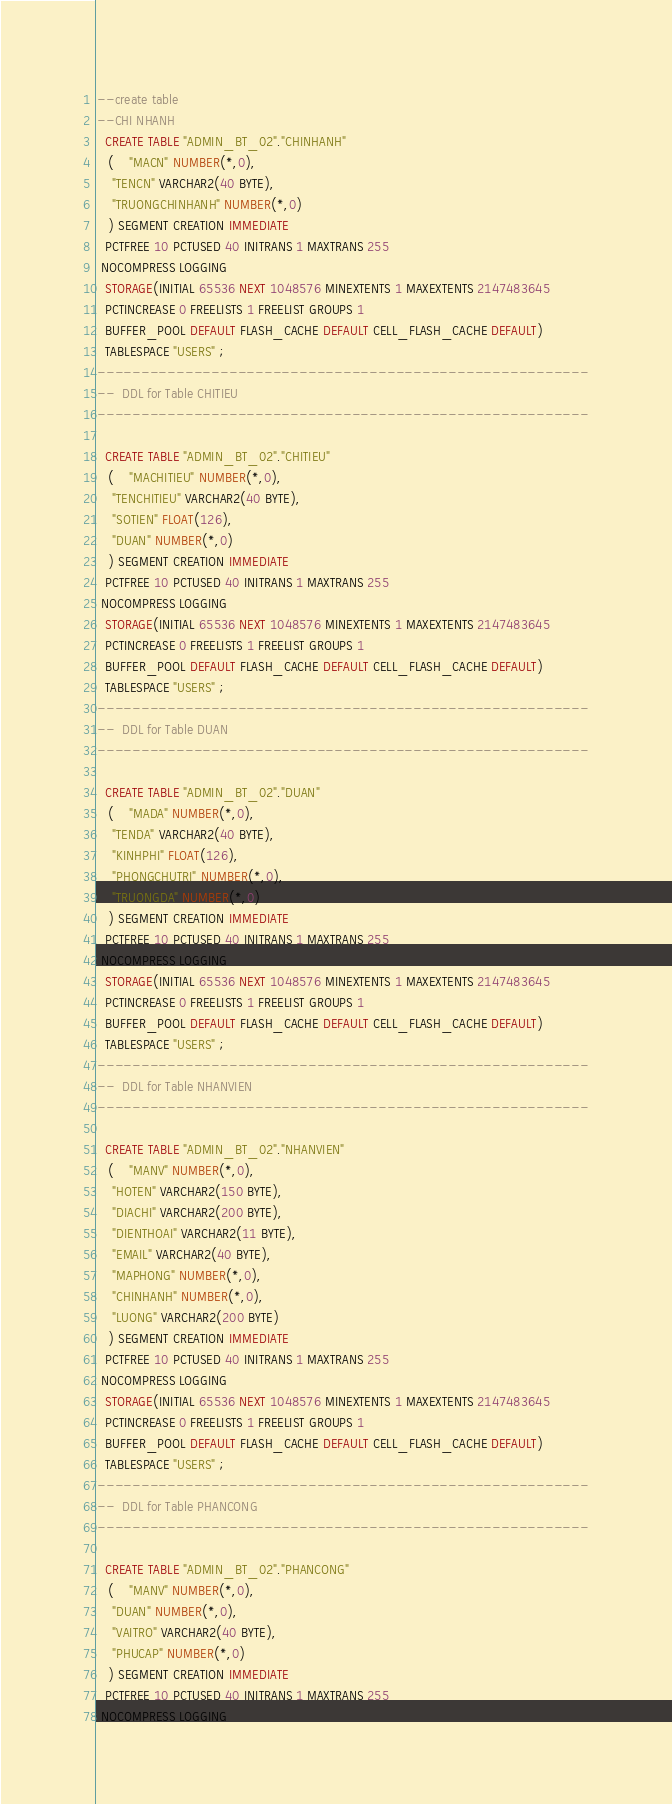<code> <loc_0><loc_0><loc_500><loc_500><_SQL_>--create table
--CHI NHANH
  CREATE TABLE "ADMIN_BT_02"."CHINHANH" 
   (	"MACN" NUMBER(*,0), 
	"TENCN" VARCHAR2(40 BYTE), 
	"TRUONGCHINHANH" NUMBER(*,0)
   ) SEGMENT CREATION IMMEDIATE 
  PCTFREE 10 PCTUSED 40 INITRANS 1 MAXTRANS 255 
 NOCOMPRESS LOGGING
  STORAGE(INITIAL 65536 NEXT 1048576 MINEXTENTS 1 MAXEXTENTS 2147483645
  PCTINCREASE 0 FREELISTS 1 FREELIST GROUPS 1
  BUFFER_POOL DEFAULT FLASH_CACHE DEFAULT CELL_FLASH_CACHE DEFAULT)
  TABLESPACE "USERS" ;
--------------------------------------------------------
--  DDL for Table CHITIEU
--------------------------------------------------------

  CREATE TABLE "ADMIN_BT_02"."CHITIEU" 
   (	"MACHITIEU" NUMBER(*,0), 
	"TENCHITIEU" VARCHAR2(40 BYTE), 
	"SOTIEN" FLOAT(126), 
	"DUAN" NUMBER(*,0)
   ) SEGMENT CREATION IMMEDIATE 
  PCTFREE 10 PCTUSED 40 INITRANS 1 MAXTRANS 255 
 NOCOMPRESS LOGGING
  STORAGE(INITIAL 65536 NEXT 1048576 MINEXTENTS 1 MAXEXTENTS 2147483645
  PCTINCREASE 0 FREELISTS 1 FREELIST GROUPS 1
  BUFFER_POOL DEFAULT FLASH_CACHE DEFAULT CELL_FLASH_CACHE DEFAULT)
  TABLESPACE "USERS" ;
--------------------------------------------------------
--  DDL for Table DUAN
--------------------------------------------------------

  CREATE TABLE "ADMIN_BT_02"."DUAN" 
   (	"MADA" NUMBER(*,0), 
	"TENDA" VARCHAR2(40 BYTE), 
	"KINHPHI" FLOAT(126), 
	"PHONGCHUTRI" NUMBER(*,0), 
	"TRUONGDA" NUMBER(*,0)
   ) SEGMENT CREATION IMMEDIATE 
  PCTFREE 10 PCTUSED 40 INITRANS 1 MAXTRANS 255 
 NOCOMPRESS LOGGING
  STORAGE(INITIAL 65536 NEXT 1048576 MINEXTENTS 1 MAXEXTENTS 2147483645
  PCTINCREASE 0 FREELISTS 1 FREELIST GROUPS 1
  BUFFER_POOL DEFAULT FLASH_CACHE DEFAULT CELL_FLASH_CACHE DEFAULT)
  TABLESPACE "USERS" ;
--------------------------------------------------------
--  DDL for Table NHANVIEN
--------------------------------------------------------

  CREATE TABLE "ADMIN_BT_02"."NHANVIEN" 
   (	"MANV" NUMBER(*,0), 
	"HOTEN" VARCHAR2(150 BYTE), 
	"DIACHI" VARCHAR2(200 BYTE), 
	"DIENTHOAI" VARCHAR2(11 BYTE), 
	"EMAIL" VARCHAR2(40 BYTE), 
	"MAPHONG" NUMBER(*,0), 
	"CHINHANH" NUMBER(*,0), 
	"LUONG" VARCHAR2(200 BYTE)
   ) SEGMENT CREATION IMMEDIATE 
  PCTFREE 10 PCTUSED 40 INITRANS 1 MAXTRANS 255 
 NOCOMPRESS LOGGING
  STORAGE(INITIAL 65536 NEXT 1048576 MINEXTENTS 1 MAXEXTENTS 2147483645
  PCTINCREASE 0 FREELISTS 1 FREELIST GROUPS 1
  BUFFER_POOL DEFAULT FLASH_CACHE DEFAULT CELL_FLASH_CACHE DEFAULT)
  TABLESPACE "USERS" ;
--------------------------------------------------------
--  DDL for Table PHANCONG
--------------------------------------------------------

  CREATE TABLE "ADMIN_BT_02"."PHANCONG" 
   (	"MANV" NUMBER(*,0), 
	"DUAN" NUMBER(*,0), 
	"VAITRO" VARCHAR2(40 BYTE), 
	"PHUCAP" NUMBER(*,0)
   ) SEGMENT CREATION IMMEDIATE 
  PCTFREE 10 PCTUSED 40 INITRANS 1 MAXTRANS 255 
 NOCOMPRESS LOGGING</code> 